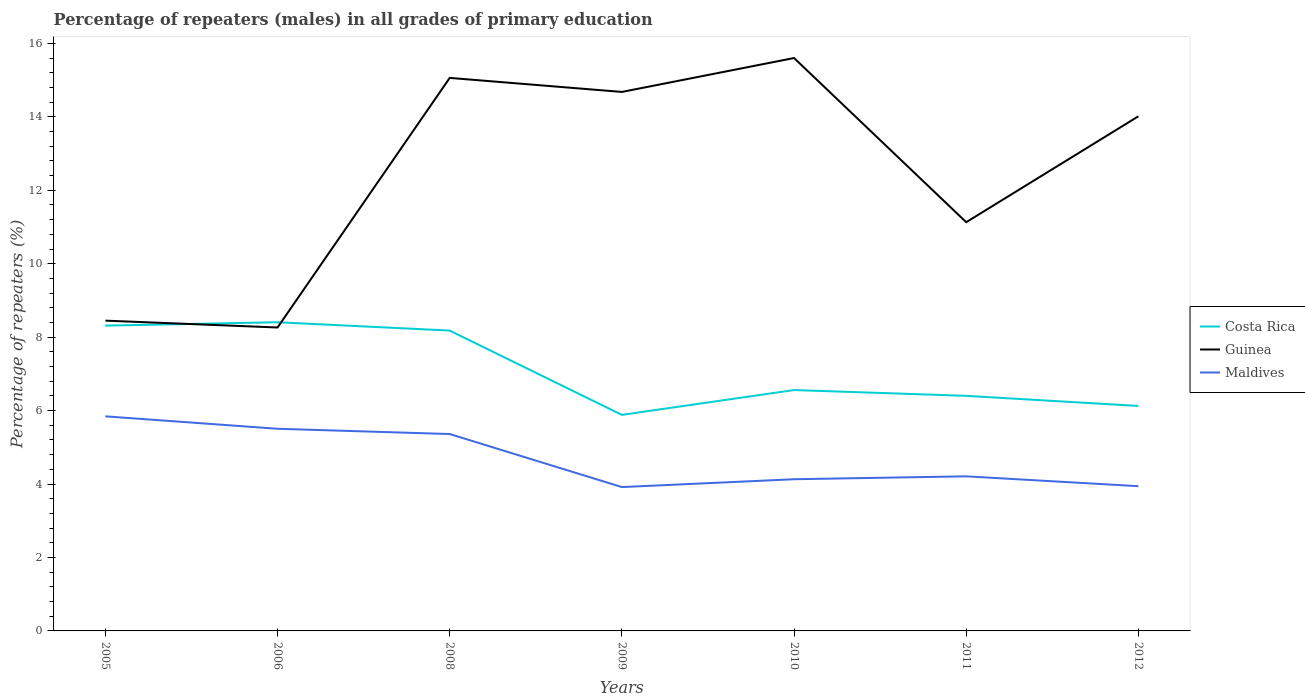How many different coloured lines are there?
Provide a succinct answer. 3. Does the line corresponding to Costa Rica intersect with the line corresponding to Guinea?
Keep it short and to the point. Yes. Is the number of lines equal to the number of legend labels?
Make the answer very short. Yes. Across all years, what is the maximum percentage of repeaters (males) in Guinea?
Your answer should be compact. 8.26. What is the total percentage of repeaters (males) in Costa Rica in the graph?
Your answer should be compact. -0.24. What is the difference between the highest and the second highest percentage of repeaters (males) in Guinea?
Your answer should be very brief. 7.34. Is the percentage of repeaters (males) in Guinea strictly greater than the percentage of repeaters (males) in Costa Rica over the years?
Keep it short and to the point. No. How many lines are there?
Give a very brief answer. 3. How many years are there in the graph?
Offer a very short reply. 7. What is the difference between two consecutive major ticks on the Y-axis?
Your response must be concise. 2. Does the graph contain grids?
Your answer should be very brief. No. Where does the legend appear in the graph?
Give a very brief answer. Center right. How many legend labels are there?
Ensure brevity in your answer.  3. What is the title of the graph?
Give a very brief answer. Percentage of repeaters (males) in all grades of primary education. What is the label or title of the Y-axis?
Your response must be concise. Percentage of repeaters (%). What is the Percentage of repeaters (%) of Costa Rica in 2005?
Your answer should be very brief. 8.31. What is the Percentage of repeaters (%) in Guinea in 2005?
Your answer should be very brief. 8.45. What is the Percentage of repeaters (%) of Maldives in 2005?
Offer a terse response. 5.84. What is the Percentage of repeaters (%) in Costa Rica in 2006?
Provide a short and direct response. 8.41. What is the Percentage of repeaters (%) of Guinea in 2006?
Offer a very short reply. 8.26. What is the Percentage of repeaters (%) of Maldives in 2006?
Provide a short and direct response. 5.5. What is the Percentage of repeaters (%) in Costa Rica in 2008?
Your response must be concise. 8.18. What is the Percentage of repeaters (%) in Guinea in 2008?
Keep it short and to the point. 15.06. What is the Percentage of repeaters (%) of Maldives in 2008?
Your response must be concise. 5.36. What is the Percentage of repeaters (%) of Costa Rica in 2009?
Your answer should be very brief. 5.88. What is the Percentage of repeaters (%) in Guinea in 2009?
Ensure brevity in your answer.  14.68. What is the Percentage of repeaters (%) of Maldives in 2009?
Your answer should be very brief. 3.92. What is the Percentage of repeaters (%) of Costa Rica in 2010?
Provide a succinct answer. 6.56. What is the Percentage of repeaters (%) of Guinea in 2010?
Provide a succinct answer. 15.6. What is the Percentage of repeaters (%) in Maldives in 2010?
Offer a very short reply. 4.13. What is the Percentage of repeaters (%) of Costa Rica in 2011?
Make the answer very short. 6.4. What is the Percentage of repeaters (%) of Guinea in 2011?
Provide a succinct answer. 11.13. What is the Percentage of repeaters (%) in Maldives in 2011?
Ensure brevity in your answer.  4.21. What is the Percentage of repeaters (%) in Costa Rica in 2012?
Offer a very short reply. 6.13. What is the Percentage of repeaters (%) in Guinea in 2012?
Your answer should be compact. 14.01. What is the Percentage of repeaters (%) in Maldives in 2012?
Make the answer very short. 3.94. Across all years, what is the maximum Percentage of repeaters (%) of Costa Rica?
Keep it short and to the point. 8.41. Across all years, what is the maximum Percentage of repeaters (%) of Guinea?
Offer a terse response. 15.6. Across all years, what is the maximum Percentage of repeaters (%) in Maldives?
Provide a succinct answer. 5.84. Across all years, what is the minimum Percentage of repeaters (%) of Costa Rica?
Your response must be concise. 5.88. Across all years, what is the minimum Percentage of repeaters (%) in Guinea?
Keep it short and to the point. 8.26. Across all years, what is the minimum Percentage of repeaters (%) in Maldives?
Your answer should be very brief. 3.92. What is the total Percentage of repeaters (%) of Costa Rica in the graph?
Offer a terse response. 49.87. What is the total Percentage of repeaters (%) of Guinea in the graph?
Provide a succinct answer. 87.19. What is the total Percentage of repeaters (%) in Maldives in the graph?
Your response must be concise. 32.91. What is the difference between the Percentage of repeaters (%) of Costa Rica in 2005 and that in 2006?
Provide a short and direct response. -0.09. What is the difference between the Percentage of repeaters (%) of Guinea in 2005 and that in 2006?
Provide a short and direct response. 0.19. What is the difference between the Percentage of repeaters (%) of Maldives in 2005 and that in 2006?
Your answer should be compact. 0.34. What is the difference between the Percentage of repeaters (%) in Costa Rica in 2005 and that in 2008?
Give a very brief answer. 0.13. What is the difference between the Percentage of repeaters (%) in Guinea in 2005 and that in 2008?
Your answer should be compact. -6.61. What is the difference between the Percentage of repeaters (%) in Maldives in 2005 and that in 2008?
Provide a succinct answer. 0.48. What is the difference between the Percentage of repeaters (%) in Costa Rica in 2005 and that in 2009?
Your response must be concise. 2.43. What is the difference between the Percentage of repeaters (%) of Guinea in 2005 and that in 2009?
Make the answer very short. -6.23. What is the difference between the Percentage of repeaters (%) in Maldives in 2005 and that in 2009?
Make the answer very short. 1.93. What is the difference between the Percentage of repeaters (%) of Costa Rica in 2005 and that in 2010?
Your answer should be compact. 1.75. What is the difference between the Percentage of repeaters (%) in Guinea in 2005 and that in 2010?
Your answer should be very brief. -7.15. What is the difference between the Percentage of repeaters (%) in Maldives in 2005 and that in 2010?
Keep it short and to the point. 1.71. What is the difference between the Percentage of repeaters (%) of Costa Rica in 2005 and that in 2011?
Your answer should be very brief. 1.91. What is the difference between the Percentage of repeaters (%) in Guinea in 2005 and that in 2011?
Provide a succinct answer. -2.68. What is the difference between the Percentage of repeaters (%) of Maldives in 2005 and that in 2011?
Your response must be concise. 1.63. What is the difference between the Percentage of repeaters (%) of Costa Rica in 2005 and that in 2012?
Your answer should be very brief. 2.19. What is the difference between the Percentage of repeaters (%) of Guinea in 2005 and that in 2012?
Ensure brevity in your answer.  -5.57. What is the difference between the Percentage of repeaters (%) of Maldives in 2005 and that in 2012?
Make the answer very short. 1.9. What is the difference between the Percentage of repeaters (%) in Costa Rica in 2006 and that in 2008?
Offer a very short reply. 0.23. What is the difference between the Percentage of repeaters (%) of Guinea in 2006 and that in 2008?
Keep it short and to the point. -6.8. What is the difference between the Percentage of repeaters (%) of Maldives in 2006 and that in 2008?
Your answer should be very brief. 0.14. What is the difference between the Percentage of repeaters (%) in Costa Rica in 2006 and that in 2009?
Give a very brief answer. 2.52. What is the difference between the Percentage of repeaters (%) of Guinea in 2006 and that in 2009?
Provide a succinct answer. -6.42. What is the difference between the Percentage of repeaters (%) in Maldives in 2006 and that in 2009?
Keep it short and to the point. 1.59. What is the difference between the Percentage of repeaters (%) in Costa Rica in 2006 and that in 2010?
Ensure brevity in your answer.  1.85. What is the difference between the Percentage of repeaters (%) in Guinea in 2006 and that in 2010?
Your response must be concise. -7.34. What is the difference between the Percentage of repeaters (%) in Maldives in 2006 and that in 2010?
Your answer should be very brief. 1.37. What is the difference between the Percentage of repeaters (%) of Costa Rica in 2006 and that in 2011?
Give a very brief answer. 2. What is the difference between the Percentage of repeaters (%) in Guinea in 2006 and that in 2011?
Offer a terse response. -2.87. What is the difference between the Percentage of repeaters (%) of Maldives in 2006 and that in 2011?
Keep it short and to the point. 1.3. What is the difference between the Percentage of repeaters (%) in Costa Rica in 2006 and that in 2012?
Offer a terse response. 2.28. What is the difference between the Percentage of repeaters (%) of Guinea in 2006 and that in 2012?
Your answer should be very brief. -5.75. What is the difference between the Percentage of repeaters (%) in Maldives in 2006 and that in 2012?
Provide a short and direct response. 1.56. What is the difference between the Percentage of repeaters (%) of Costa Rica in 2008 and that in 2009?
Your answer should be compact. 2.3. What is the difference between the Percentage of repeaters (%) of Guinea in 2008 and that in 2009?
Ensure brevity in your answer.  0.38. What is the difference between the Percentage of repeaters (%) of Maldives in 2008 and that in 2009?
Offer a very short reply. 1.44. What is the difference between the Percentage of repeaters (%) in Costa Rica in 2008 and that in 2010?
Offer a terse response. 1.62. What is the difference between the Percentage of repeaters (%) in Guinea in 2008 and that in 2010?
Keep it short and to the point. -0.54. What is the difference between the Percentage of repeaters (%) in Maldives in 2008 and that in 2010?
Provide a succinct answer. 1.23. What is the difference between the Percentage of repeaters (%) in Costa Rica in 2008 and that in 2011?
Make the answer very short. 1.78. What is the difference between the Percentage of repeaters (%) of Guinea in 2008 and that in 2011?
Provide a short and direct response. 3.93. What is the difference between the Percentage of repeaters (%) of Maldives in 2008 and that in 2011?
Provide a succinct answer. 1.15. What is the difference between the Percentage of repeaters (%) in Costa Rica in 2008 and that in 2012?
Offer a terse response. 2.05. What is the difference between the Percentage of repeaters (%) in Guinea in 2008 and that in 2012?
Provide a succinct answer. 1.04. What is the difference between the Percentage of repeaters (%) of Maldives in 2008 and that in 2012?
Keep it short and to the point. 1.42. What is the difference between the Percentage of repeaters (%) of Costa Rica in 2009 and that in 2010?
Your answer should be compact. -0.68. What is the difference between the Percentage of repeaters (%) in Guinea in 2009 and that in 2010?
Make the answer very short. -0.92. What is the difference between the Percentage of repeaters (%) of Maldives in 2009 and that in 2010?
Give a very brief answer. -0.21. What is the difference between the Percentage of repeaters (%) of Costa Rica in 2009 and that in 2011?
Provide a succinct answer. -0.52. What is the difference between the Percentage of repeaters (%) of Guinea in 2009 and that in 2011?
Provide a short and direct response. 3.55. What is the difference between the Percentage of repeaters (%) of Maldives in 2009 and that in 2011?
Offer a terse response. -0.29. What is the difference between the Percentage of repeaters (%) in Costa Rica in 2009 and that in 2012?
Provide a succinct answer. -0.24. What is the difference between the Percentage of repeaters (%) of Guinea in 2009 and that in 2012?
Your answer should be compact. 0.66. What is the difference between the Percentage of repeaters (%) in Maldives in 2009 and that in 2012?
Your response must be concise. -0.02. What is the difference between the Percentage of repeaters (%) of Costa Rica in 2010 and that in 2011?
Your answer should be very brief. 0.16. What is the difference between the Percentage of repeaters (%) in Guinea in 2010 and that in 2011?
Make the answer very short. 4.47. What is the difference between the Percentage of repeaters (%) in Maldives in 2010 and that in 2011?
Keep it short and to the point. -0.08. What is the difference between the Percentage of repeaters (%) in Costa Rica in 2010 and that in 2012?
Keep it short and to the point. 0.43. What is the difference between the Percentage of repeaters (%) of Guinea in 2010 and that in 2012?
Your response must be concise. 1.59. What is the difference between the Percentage of repeaters (%) of Maldives in 2010 and that in 2012?
Make the answer very short. 0.19. What is the difference between the Percentage of repeaters (%) in Costa Rica in 2011 and that in 2012?
Provide a succinct answer. 0.28. What is the difference between the Percentage of repeaters (%) of Guinea in 2011 and that in 2012?
Give a very brief answer. -2.88. What is the difference between the Percentage of repeaters (%) in Maldives in 2011 and that in 2012?
Your response must be concise. 0.27. What is the difference between the Percentage of repeaters (%) of Costa Rica in 2005 and the Percentage of repeaters (%) of Guinea in 2006?
Ensure brevity in your answer.  0.05. What is the difference between the Percentage of repeaters (%) in Costa Rica in 2005 and the Percentage of repeaters (%) in Maldives in 2006?
Your answer should be compact. 2.81. What is the difference between the Percentage of repeaters (%) of Guinea in 2005 and the Percentage of repeaters (%) of Maldives in 2006?
Provide a short and direct response. 2.94. What is the difference between the Percentage of repeaters (%) in Costa Rica in 2005 and the Percentage of repeaters (%) in Guinea in 2008?
Your answer should be compact. -6.75. What is the difference between the Percentage of repeaters (%) in Costa Rica in 2005 and the Percentage of repeaters (%) in Maldives in 2008?
Make the answer very short. 2.95. What is the difference between the Percentage of repeaters (%) of Guinea in 2005 and the Percentage of repeaters (%) of Maldives in 2008?
Give a very brief answer. 3.09. What is the difference between the Percentage of repeaters (%) of Costa Rica in 2005 and the Percentage of repeaters (%) of Guinea in 2009?
Give a very brief answer. -6.36. What is the difference between the Percentage of repeaters (%) of Costa Rica in 2005 and the Percentage of repeaters (%) of Maldives in 2009?
Make the answer very short. 4.4. What is the difference between the Percentage of repeaters (%) of Guinea in 2005 and the Percentage of repeaters (%) of Maldives in 2009?
Keep it short and to the point. 4.53. What is the difference between the Percentage of repeaters (%) in Costa Rica in 2005 and the Percentage of repeaters (%) in Guinea in 2010?
Provide a succinct answer. -7.29. What is the difference between the Percentage of repeaters (%) in Costa Rica in 2005 and the Percentage of repeaters (%) in Maldives in 2010?
Keep it short and to the point. 4.18. What is the difference between the Percentage of repeaters (%) of Guinea in 2005 and the Percentage of repeaters (%) of Maldives in 2010?
Give a very brief answer. 4.32. What is the difference between the Percentage of repeaters (%) of Costa Rica in 2005 and the Percentage of repeaters (%) of Guinea in 2011?
Provide a short and direct response. -2.82. What is the difference between the Percentage of repeaters (%) in Costa Rica in 2005 and the Percentage of repeaters (%) in Maldives in 2011?
Provide a short and direct response. 4.1. What is the difference between the Percentage of repeaters (%) in Guinea in 2005 and the Percentage of repeaters (%) in Maldives in 2011?
Your answer should be very brief. 4.24. What is the difference between the Percentage of repeaters (%) in Costa Rica in 2005 and the Percentage of repeaters (%) in Guinea in 2012?
Offer a terse response. -5.7. What is the difference between the Percentage of repeaters (%) in Costa Rica in 2005 and the Percentage of repeaters (%) in Maldives in 2012?
Ensure brevity in your answer.  4.37. What is the difference between the Percentage of repeaters (%) of Guinea in 2005 and the Percentage of repeaters (%) of Maldives in 2012?
Your answer should be very brief. 4.51. What is the difference between the Percentage of repeaters (%) of Costa Rica in 2006 and the Percentage of repeaters (%) of Guinea in 2008?
Ensure brevity in your answer.  -6.65. What is the difference between the Percentage of repeaters (%) in Costa Rica in 2006 and the Percentage of repeaters (%) in Maldives in 2008?
Offer a terse response. 3.04. What is the difference between the Percentage of repeaters (%) in Guinea in 2006 and the Percentage of repeaters (%) in Maldives in 2008?
Your answer should be very brief. 2.9. What is the difference between the Percentage of repeaters (%) in Costa Rica in 2006 and the Percentage of repeaters (%) in Guinea in 2009?
Provide a succinct answer. -6.27. What is the difference between the Percentage of repeaters (%) of Costa Rica in 2006 and the Percentage of repeaters (%) of Maldives in 2009?
Make the answer very short. 4.49. What is the difference between the Percentage of repeaters (%) of Guinea in 2006 and the Percentage of repeaters (%) of Maldives in 2009?
Make the answer very short. 4.35. What is the difference between the Percentage of repeaters (%) of Costa Rica in 2006 and the Percentage of repeaters (%) of Guinea in 2010?
Offer a very short reply. -7.2. What is the difference between the Percentage of repeaters (%) in Costa Rica in 2006 and the Percentage of repeaters (%) in Maldives in 2010?
Ensure brevity in your answer.  4.27. What is the difference between the Percentage of repeaters (%) in Guinea in 2006 and the Percentage of repeaters (%) in Maldives in 2010?
Ensure brevity in your answer.  4.13. What is the difference between the Percentage of repeaters (%) of Costa Rica in 2006 and the Percentage of repeaters (%) of Guinea in 2011?
Ensure brevity in your answer.  -2.72. What is the difference between the Percentage of repeaters (%) in Costa Rica in 2006 and the Percentage of repeaters (%) in Maldives in 2011?
Your answer should be compact. 4.2. What is the difference between the Percentage of repeaters (%) of Guinea in 2006 and the Percentage of repeaters (%) of Maldives in 2011?
Your answer should be compact. 4.05. What is the difference between the Percentage of repeaters (%) in Costa Rica in 2006 and the Percentage of repeaters (%) in Guinea in 2012?
Your answer should be very brief. -5.61. What is the difference between the Percentage of repeaters (%) in Costa Rica in 2006 and the Percentage of repeaters (%) in Maldives in 2012?
Give a very brief answer. 4.46. What is the difference between the Percentage of repeaters (%) of Guinea in 2006 and the Percentage of repeaters (%) of Maldives in 2012?
Your response must be concise. 4.32. What is the difference between the Percentage of repeaters (%) of Costa Rica in 2008 and the Percentage of repeaters (%) of Guinea in 2009?
Your response must be concise. -6.5. What is the difference between the Percentage of repeaters (%) of Costa Rica in 2008 and the Percentage of repeaters (%) of Maldives in 2009?
Your answer should be compact. 4.26. What is the difference between the Percentage of repeaters (%) in Guinea in 2008 and the Percentage of repeaters (%) in Maldives in 2009?
Offer a terse response. 11.14. What is the difference between the Percentage of repeaters (%) of Costa Rica in 2008 and the Percentage of repeaters (%) of Guinea in 2010?
Provide a succinct answer. -7.42. What is the difference between the Percentage of repeaters (%) in Costa Rica in 2008 and the Percentage of repeaters (%) in Maldives in 2010?
Your answer should be compact. 4.05. What is the difference between the Percentage of repeaters (%) in Guinea in 2008 and the Percentage of repeaters (%) in Maldives in 2010?
Offer a terse response. 10.93. What is the difference between the Percentage of repeaters (%) of Costa Rica in 2008 and the Percentage of repeaters (%) of Guinea in 2011?
Make the answer very short. -2.95. What is the difference between the Percentage of repeaters (%) of Costa Rica in 2008 and the Percentage of repeaters (%) of Maldives in 2011?
Keep it short and to the point. 3.97. What is the difference between the Percentage of repeaters (%) in Guinea in 2008 and the Percentage of repeaters (%) in Maldives in 2011?
Give a very brief answer. 10.85. What is the difference between the Percentage of repeaters (%) of Costa Rica in 2008 and the Percentage of repeaters (%) of Guinea in 2012?
Ensure brevity in your answer.  -5.84. What is the difference between the Percentage of repeaters (%) in Costa Rica in 2008 and the Percentage of repeaters (%) in Maldives in 2012?
Ensure brevity in your answer.  4.24. What is the difference between the Percentage of repeaters (%) of Guinea in 2008 and the Percentage of repeaters (%) of Maldives in 2012?
Give a very brief answer. 11.12. What is the difference between the Percentage of repeaters (%) in Costa Rica in 2009 and the Percentage of repeaters (%) in Guinea in 2010?
Keep it short and to the point. -9.72. What is the difference between the Percentage of repeaters (%) in Costa Rica in 2009 and the Percentage of repeaters (%) in Maldives in 2010?
Make the answer very short. 1.75. What is the difference between the Percentage of repeaters (%) in Guinea in 2009 and the Percentage of repeaters (%) in Maldives in 2010?
Your answer should be very brief. 10.55. What is the difference between the Percentage of repeaters (%) in Costa Rica in 2009 and the Percentage of repeaters (%) in Guinea in 2011?
Ensure brevity in your answer.  -5.25. What is the difference between the Percentage of repeaters (%) of Costa Rica in 2009 and the Percentage of repeaters (%) of Maldives in 2011?
Your answer should be compact. 1.67. What is the difference between the Percentage of repeaters (%) in Guinea in 2009 and the Percentage of repeaters (%) in Maldives in 2011?
Your response must be concise. 10.47. What is the difference between the Percentage of repeaters (%) of Costa Rica in 2009 and the Percentage of repeaters (%) of Guinea in 2012?
Offer a very short reply. -8.13. What is the difference between the Percentage of repeaters (%) in Costa Rica in 2009 and the Percentage of repeaters (%) in Maldives in 2012?
Make the answer very short. 1.94. What is the difference between the Percentage of repeaters (%) in Guinea in 2009 and the Percentage of repeaters (%) in Maldives in 2012?
Offer a very short reply. 10.74. What is the difference between the Percentage of repeaters (%) of Costa Rica in 2010 and the Percentage of repeaters (%) of Guinea in 2011?
Your answer should be compact. -4.57. What is the difference between the Percentage of repeaters (%) in Costa Rica in 2010 and the Percentage of repeaters (%) in Maldives in 2011?
Offer a very short reply. 2.35. What is the difference between the Percentage of repeaters (%) of Guinea in 2010 and the Percentage of repeaters (%) of Maldives in 2011?
Offer a very short reply. 11.39. What is the difference between the Percentage of repeaters (%) in Costa Rica in 2010 and the Percentage of repeaters (%) in Guinea in 2012?
Offer a very short reply. -7.46. What is the difference between the Percentage of repeaters (%) in Costa Rica in 2010 and the Percentage of repeaters (%) in Maldives in 2012?
Keep it short and to the point. 2.62. What is the difference between the Percentage of repeaters (%) in Guinea in 2010 and the Percentage of repeaters (%) in Maldives in 2012?
Give a very brief answer. 11.66. What is the difference between the Percentage of repeaters (%) in Costa Rica in 2011 and the Percentage of repeaters (%) in Guinea in 2012?
Make the answer very short. -7.61. What is the difference between the Percentage of repeaters (%) of Costa Rica in 2011 and the Percentage of repeaters (%) of Maldives in 2012?
Offer a very short reply. 2.46. What is the difference between the Percentage of repeaters (%) of Guinea in 2011 and the Percentage of repeaters (%) of Maldives in 2012?
Keep it short and to the point. 7.19. What is the average Percentage of repeaters (%) in Costa Rica per year?
Offer a terse response. 7.12. What is the average Percentage of repeaters (%) of Guinea per year?
Your answer should be very brief. 12.46. What is the average Percentage of repeaters (%) of Maldives per year?
Offer a very short reply. 4.7. In the year 2005, what is the difference between the Percentage of repeaters (%) of Costa Rica and Percentage of repeaters (%) of Guinea?
Provide a succinct answer. -0.14. In the year 2005, what is the difference between the Percentage of repeaters (%) in Costa Rica and Percentage of repeaters (%) in Maldives?
Ensure brevity in your answer.  2.47. In the year 2005, what is the difference between the Percentage of repeaters (%) of Guinea and Percentage of repeaters (%) of Maldives?
Give a very brief answer. 2.61. In the year 2006, what is the difference between the Percentage of repeaters (%) in Costa Rica and Percentage of repeaters (%) in Guinea?
Your response must be concise. 0.14. In the year 2006, what is the difference between the Percentage of repeaters (%) of Costa Rica and Percentage of repeaters (%) of Maldives?
Offer a terse response. 2.9. In the year 2006, what is the difference between the Percentage of repeaters (%) of Guinea and Percentage of repeaters (%) of Maldives?
Your response must be concise. 2.76. In the year 2008, what is the difference between the Percentage of repeaters (%) in Costa Rica and Percentage of repeaters (%) in Guinea?
Your answer should be compact. -6.88. In the year 2008, what is the difference between the Percentage of repeaters (%) of Costa Rica and Percentage of repeaters (%) of Maldives?
Offer a very short reply. 2.82. In the year 2008, what is the difference between the Percentage of repeaters (%) of Guinea and Percentage of repeaters (%) of Maldives?
Keep it short and to the point. 9.7. In the year 2009, what is the difference between the Percentage of repeaters (%) of Costa Rica and Percentage of repeaters (%) of Guinea?
Ensure brevity in your answer.  -8.79. In the year 2009, what is the difference between the Percentage of repeaters (%) of Costa Rica and Percentage of repeaters (%) of Maldives?
Make the answer very short. 1.97. In the year 2009, what is the difference between the Percentage of repeaters (%) in Guinea and Percentage of repeaters (%) in Maldives?
Your answer should be very brief. 10.76. In the year 2010, what is the difference between the Percentage of repeaters (%) of Costa Rica and Percentage of repeaters (%) of Guinea?
Give a very brief answer. -9.04. In the year 2010, what is the difference between the Percentage of repeaters (%) in Costa Rica and Percentage of repeaters (%) in Maldives?
Your response must be concise. 2.43. In the year 2010, what is the difference between the Percentage of repeaters (%) in Guinea and Percentage of repeaters (%) in Maldives?
Make the answer very short. 11.47. In the year 2011, what is the difference between the Percentage of repeaters (%) in Costa Rica and Percentage of repeaters (%) in Guinea?
Offer a terse response. -4.73. In the year 2011, what is the difference between the Percentage of repeaters (%) of Costa Rica and Percentage of repeaters (%) of Maldives?
Provide a succinct answer. 2.19. In the year 2011, what is the difference between the Percentage of repeaters (%) in Guinea and Percentage of repeaters (%) in Maldives?
Offer a very short reply. 6.92. In the year 2012, what is the difference between the Percentage of repeaters (%) in Costa Rica and Percentage of repeaters (%) in Guinea?
Provide a succinct answer. -7.89. In the year 2012, what is the difference between the Percentage of repeaters (%) in Costa Rica and Percentage of repeaters (%) in Maldives?
Provide a succinct answer. 2.18. In the year 2012, what is the difference between the Percentage of repeaters (%) in Guinea and Percentage of repeaters (%) in Maldives?
Offer a very short reply. 10.07. What is the ratio of the Percentage of repeaters (%) of Costa Rica in 2005 to that in 2006?
Provide a succinct answer. 0.99. What is the ratio of the Percentage of repeaters (%) of Guinea in 2005 to that in 2006?
Keep it short and to the point. 1.02. What is the ratio of the Percentage of repeaters (%) in Maldives in 2005 to that in 2006?
Your response must be concise. 1.06. What is the ratio of the Percentage of repeaters (%) of Costa Rica in 2005 to that in 2008?
Offer a terse response. 1.02. What is the ratio of the Percentage of repeaters (%) of Guinea in 2005 to that in 2008?
Provide a succinct answer. 0.56. What is the ratio of the Percentage of repeaters (%) of Maldives in 2005 to that in 2008?
Provide a short and direct response. 1.09. What is the ratio of the Percentage of repeaters (%) in Costa Rica in 2005 to that in 2009?
Your answer should be very brief. 1.41. What is the ratio of the Percentage of repeaters (%) of Guinea in 2005 to that in 2009?
Ensure brevity in your answer.  0.58. What is the ratio of the Percentage of repeaters (%) of Maldives in 2005 to that in 2009?
Provide a short and direct response. 1.49. What is the ratio of the Percentage of repeaters (%) in Costa Rica in 2005 to that in 2010?
Give a very brief answer. 1.27. What is the ratio of the Percentage of repeaters (%) of Guinea in 2005 to that in 2010?
Ensure brevity in your answer.  0.54. What is the ratio of the Percentage of repeaters (%) in Maldives in 2005 to that in 2010?
Your response must be concise. 1.41. What is the ratio of the Percentage of repeaters (%) of Costa Rica in 2005 to that in 2011?
Provide a short and direct response. 1.3. What is the ratio of the Percentage of repeaters (%) in Guinea in 2005 to that in 2011?
Your answer should be compact. 0.76. What is the ratio of the Percentage of repeaters (%) of Maldives in 2005 to that in 2011?
Give a very brief answer. 1.39. What is the ratio of the Percentage of repeaters (%) of Costa Rica in 2005 to that in 2012?
Make the answer very short. 1.36. What is the ratio of the Percentage of repeaters (%) in Guinea in 2005 to that in 2012?
Your response must be concise. 0.6. What is the ratio of the Percentage of repeaters (%) of Maldives in 2005 to that in 2012?
Your answer should be compact. 1.48. What is the ratio of the Percentage of repeaters (%) in Costa Rica in 2006 to that in 2008?
Provide a short and direct response. 1.03. What is the ratio of the Percentage of repeaters (%) in Guinea in 2006 to that in 2008?
Keep it short and to the point. 0.55. What is the ratio of the Percentage of repeaters (%) in Maldives in 2006 to that in 2008?
Keep it short and to the point. 1.03. What is the ratio of the Percentage of repeaters (%) in Costa Rica in 2006 to that in 2009?
Offer a very short reply. 1.43. What is the ratio of the Percentage of repeaters (%) in Guinea in 2006 to that in 2009?
Offer a very short reply. 0.56. What is the ratio of the Percentage of repeaters (%) of Maldives in 2006 to that in 2009?
Ensure brevity in your answer.  1.41. What is the ratio of the Percentage of repeaters (%) of Costa Rica in 2006 to that in 2010?
Provide a succinct answer. 1.28. What is the ratio of the Percentage of repeaters (%) in Guinea in 2006 to that in 2010?
Provide a succinct answer. 0.53. What is the ratio of the Percentage of repeaters (%) in Maldives in 2006 to that in 2010?
Ensure brevity in your answer.  1.33. What is the ratio of the Percentage of repeaters (%) of Costa Rica in 2006 to that in 2011?
Provide a short and direct response. 1.31. What is the ratio of the Percentage of repeaters (%) of Guinea in 2006 to that in 2011?
Offer a terse response. 0.74. What is the ratio of the Percentage of repeaters (%) of Maldives in 2006 to that in 2011?
Give a very brief answer. 1.31. What is the ratio of the Percentage of repeaters (%) in Costa Rica in 2006 to that in 2012?
Provide a succinct answer. 1.37. What is the ratio of the Percentage of repeaters (%) in Guinea in 2006 to that in 2012?
Offer a very short reply. 0.59. What is the ratio of the Percentage of repeaters (%) of Maldives in 2006 to that in 2012?
Your answer should be compact. 1.4. What is the ratio of the Percentage of repeaters (%) of Costa Rica in 2008 to that in 2009?
Keep it short and to the point. 1.39. What is the ratio of the Percentage of repeaters (%) of Maldives in 2008 to that in 2009?
Keep it short and to the point. 1.37. What is the ratio of the Percentage of repeaters (%) in Costa Rica in 2008 to that in 2010?
Offer a terse response. 1.25. What is the ratio of the Percentage of repeaters (%) of Guinea in 2008 to that in 2010?
Provide a short and direct response. 0.97. What is the ratio of the Percentage of repeaters (%) in Maldives in 2008 to that in 2010?
Offer a very short reply. 1.3. What is the ratio of the Percentage of repeaters (%) in Costa Rica in 2008 to that in 2011?
Provide a short and direct response. 1.28. What is the ratio of the Percentage of repeaters (%) of Guinea in 2008 to that in 2011?
Your answer should be compact. 1.35. What is the ratio of the Percentage of repeaters (%) of Maldives in 2008 to that in 2011?
Ensure brevity in your answer.  1.27. What is the ratio of the Percentage of repeaters (%) of Costa Rica in 2008 to that in 2012?
Your answer should be very brief. 1.34. What is the ratio of the Percentage of repeaters (%) of Guinea in 2008 to that in 2012?
Your answer should be very brief. 1.07. What is the ratio of the Percentage of repeaters (%) in Maldives in 2008 to that in 2012?
Your response must be concise. 1.36. What is the ratio of the Percentage of repeaters (%) in Costa Rica in 2009 to that in 2010?
Provide a succinct answer. 0.9. What is the ratio of the Percentage of repeaters (%) in Guinea in 2009 to that in 2010?
Offer a very short reply. 0.94. What is the ratio of the Percentage of repeaters (%) in Maldives in 2009 to that in 2010?
Offer a very short reply. 0.95. What is the ratio of the Percentage of repeaters (%) in Costa Rica in 2009 to that in 2011?
Provide a succinct answer. 0.92. What is the ratio of the Percentage of repeaters (%) of Guinea in 2009 to that in 2011?
Provide a succinct answer. 1.32. What is the ratio of the Percentage of repeaters (%) of Maldives in 2009 to that in 2011?
Ensure brevity in your answer.  0.93. What is the ratio of the Percentage of repeaters (%) of Costa Rica in 2009 to that in 2012?
Offer a very short reply. 0.96. What is the ratio of the Percentage of repeaters (%) of Guinea in 2009 to that in 2012?
Offer a terse response. 1.05. What is the ratio of the Percentage of repeaters (%) of Costa Rica in 2010 to that in 2011?
Offer a terse response. 1.02. What is the ratio of the Percentage of repeaters (%) in Guinea in 2010 to that in 2011?
Offer a terse response. 1.4. What is the ratio of the Percentage of repeaters (%) of Maldives in 2010 to that in 2011?
Make the answer very short. 0.98. What is the ratio of the Percentage of repeaters (%) of Costa Rica in 2010 to that in 2012?
Your response must be concise. 1.07. What is the ratio of the Percentage of repeaters (%) of Guinea in 2010 to that in 2012?
Your answer should be very brief. 1.11. What is the ratio of the Percentage of repeaters (%) in Maldives in 2010 to that in 2012?
Your answer should be very brief. 1.05. What is the ratio of the Percentage of repeaters (%) in Costa Rica in 2011 to that in 2012?
Your response must be concise. 1.04. What is the ratio of the Percentage of repeaters (%) in Guinea in 2011 to that in 2012?
Offer a terse response. 0.79. What is the ratio of the Percentage of repeaters (%) in Maldives in 2011 to that in 2012?
Keep it short and to the point. 1.07. What is the difference between the highest and the second highest Percentage of repeaters (%) of Costa Rica?
Provide a succinct answer. 0.09. What is the difference between the highest and the second highest Percentage of repeaters (%) in Guinea?
Your response must be concise. 0.54. What is the difference between the highest and the second highest Percentage of repeaters (%) of Maldives?
Offer a very short reply. 0.34. What is the difference between the highest and the lowest Percentage of repeaters (%) of Costa Rica?
Provide a succinct answer. 2.52. What is the difference between the highest and the lowest Percentage of repeaters (%) of Guinea?
Make the answer very short. 7.34. What is the difference between the highest and the lowest Percentage of repeaters (%) in Maldives?
Give a very brief answer. 1.93. 